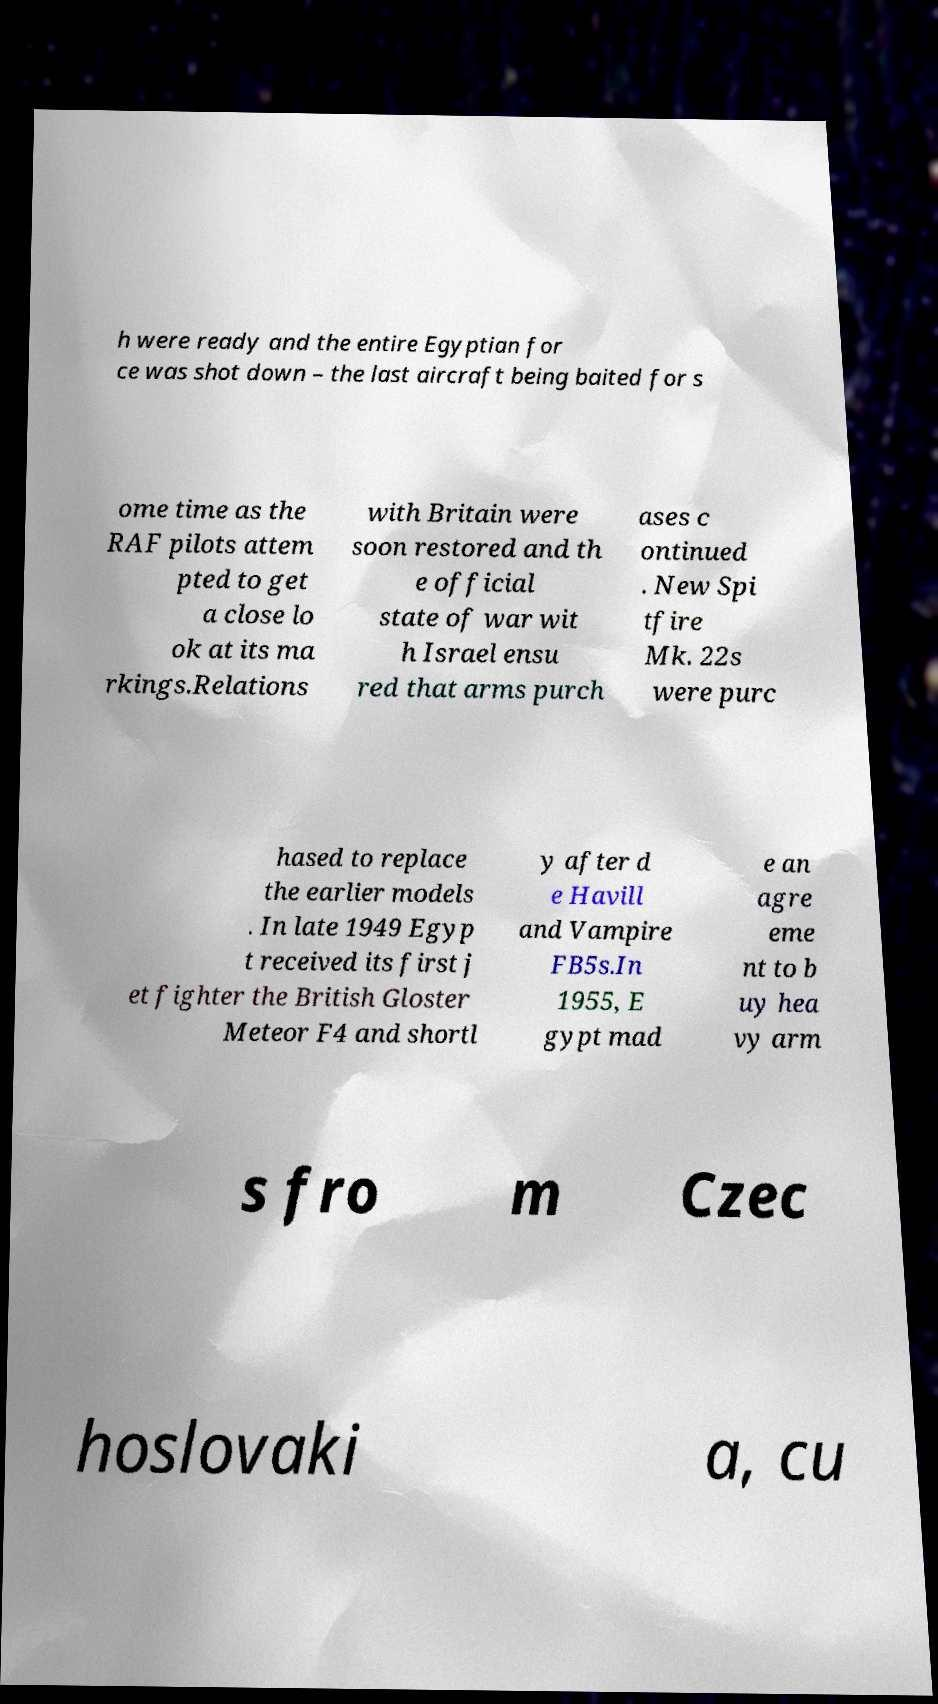What messages or text are displayed in this image? I need them in a readable, typed format. h were ready and the entire Egyptian for ce was shot down – the last aircraft being baited for s ome time as the RAF pilots attem pted to get a close lo ok at its ma rkings.Relations with Britain were soon restored and th e official state of war wit h Israel ensu red that arms purch ases c ontinued . New Spi tfire Mk. 22s were purc hased to replace the earlier models . In late 1949 Egyp t received its first j et fighter the British Gloster Meteor F4 and shortl y after d e Havill and Vampire FB5s.In 1955, E gypt mad e an agre eme nt to b uy hea vy arm s fro m Czec hoslovaki a, cu 